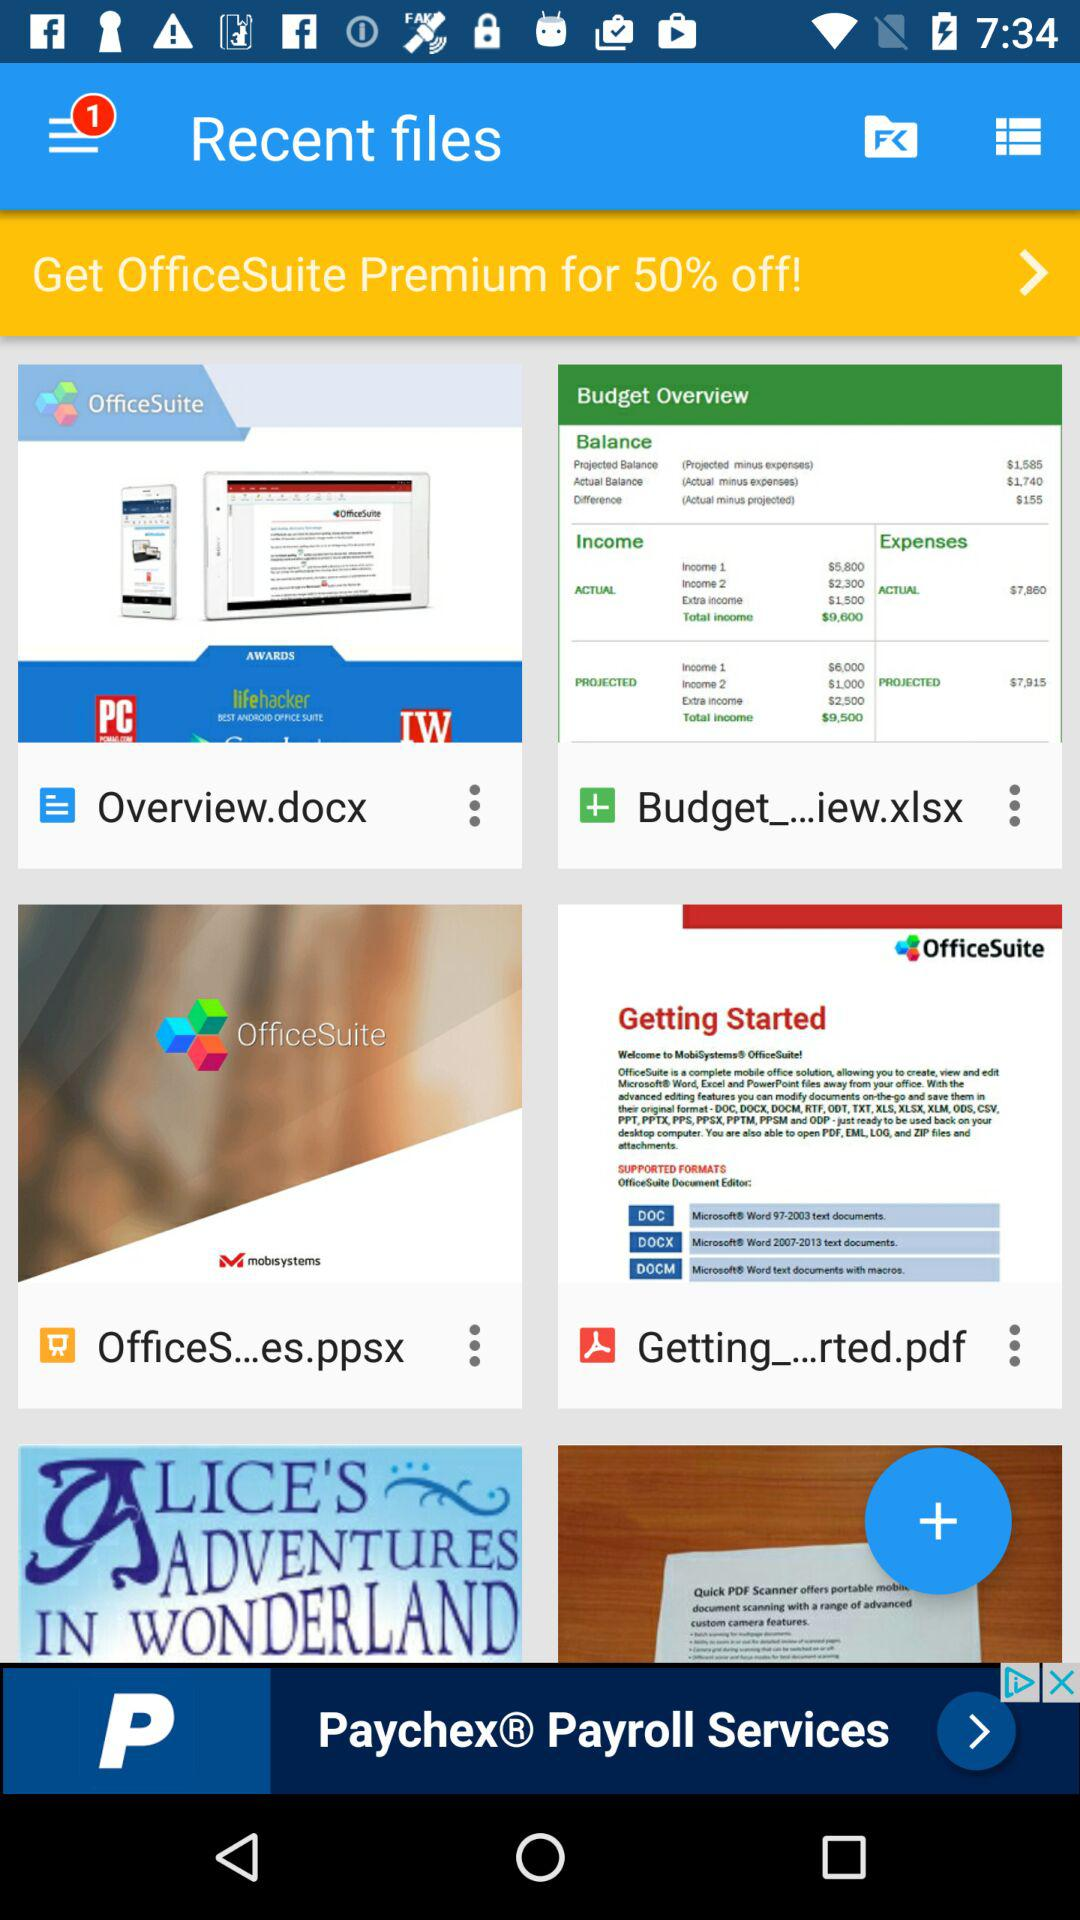How many unread notifications are there? There is 1 unread notification. 